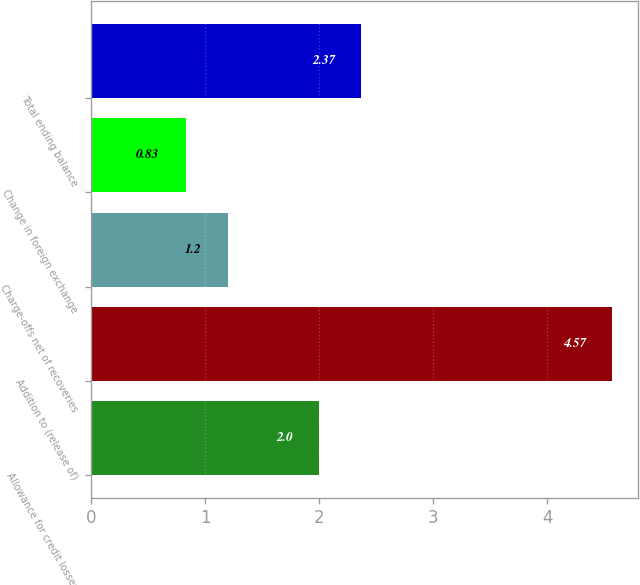<chart> <loc_0><loc_0><loc_500><loc_500><bar_chart><fcel>Allowance for credit losses<fcel>Addition to (release of)<fcel>Charge-offs net of recoveries<fcel>Change in foreign exchange<fcel>Total ending balance<nl><fcel>2<fcel>4.57<fcel>1.2<fcel>0.83<fcel>2.37<nl></chart> 